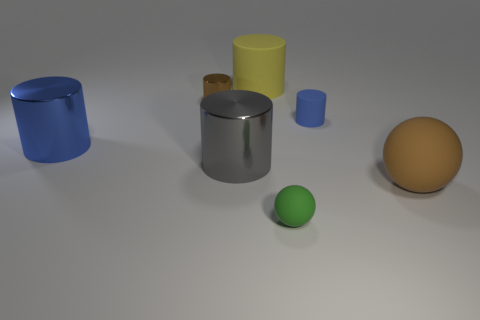Add 6 big shiny things. How many big shiny things exist? 8 Add 3 green blocks. How many objects exist? 10 Subtract all blue cylinders. How many cylinders are left? 3 Subtract all blue metal cylinders. How many cylinders are left? 4 Subtract 1 yellow cylinders. How many objects are left? 6 Subtract all cylinders. How many objects are left? 2 Subtract 1 cylinders. How many cylinders are left? 4 Subtract all red cylinders. Subtract all blue blocks. How many cylinders are left? 5 Subtract all red cylinders. How many green spheres are left? 1 Subtract all blue things. Subtract all rubber balls. How many objects are left? 3 